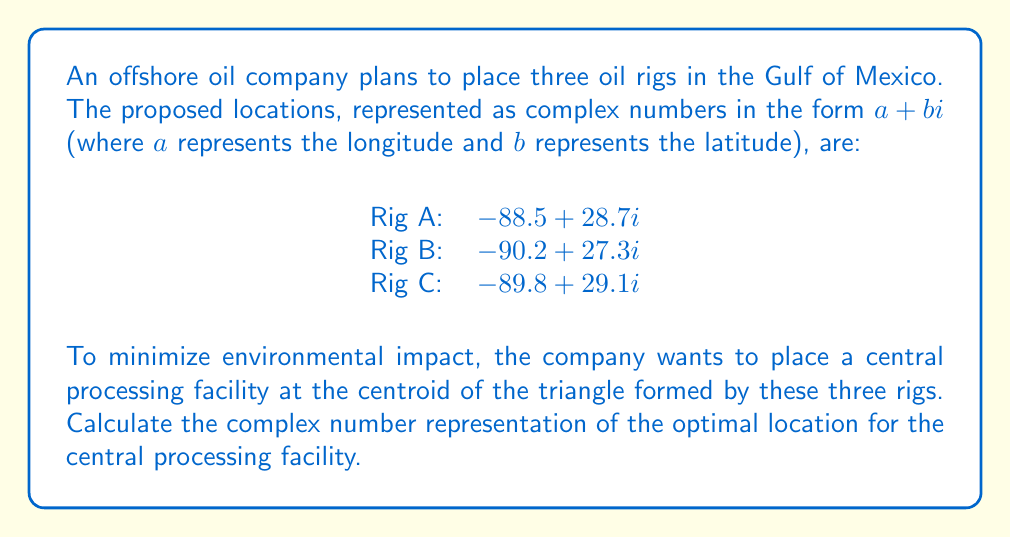Can you solve this math problem? To find the centroid of a triangle represented by complex numbers, we can follow these steps:

1) The centroid of a triangle is located at the arithmetic mean of its three vertices.

2) Given the complex numbers for the three rigs:
   Rig A: $z_1 = -88.5 + 28.7i$
   Rig B: $z_2 = -90.2 + 27.3i$
   Rig C: $z_3 = -89.8 + 29.1i$

3) The centroid $z_c$ is calculated as:

   $$z_c = \frac{z_1 + z_2 + z_3}{3}$$

4) Substituting the values:

   $$z_c = \frac{(-88.5 + 28.7i) + (-90.2 + 27.3i) + (-89.8 + 29.1i)}{3}$$

5) Simplifying the numerator:

   $$z_c = \frac{-268.5 + 85.1i}{3}$$

6) Dividing both the real and imaginary parts by 3:

   $$z_c = -89.5 + 28.3666...i$$

7) Rounding to one decimal place for consistency with the input data:

   $$z_c = -89.5 + 28.4i$$

This complex number represents the optimal location for the central processing facility, where -89.5 is the longitude and 28.4 is the latitude.
Answer: $-89.5 + 28.4i$ 